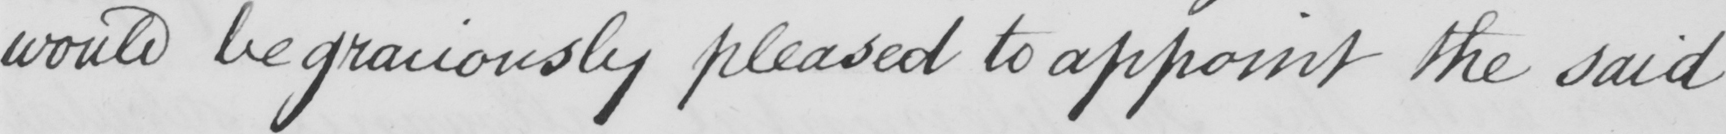Can you tell me what this handwritten text says? would be graciously pleased to appoint the said 